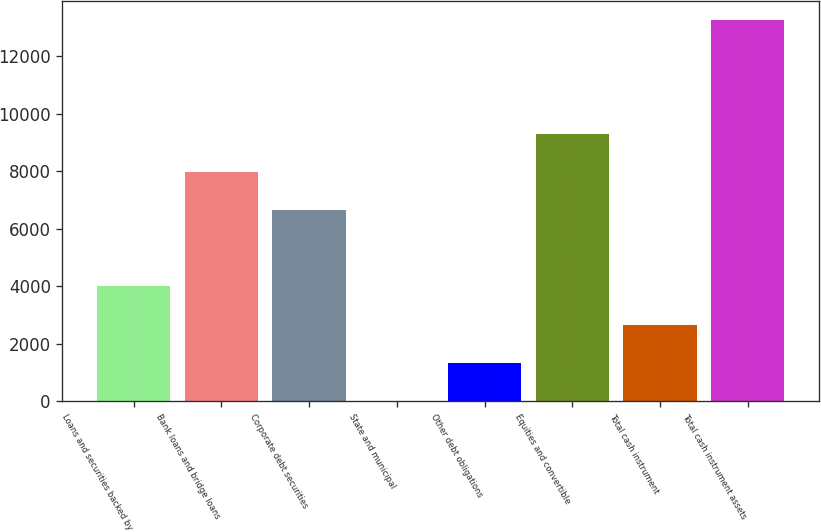Convert chart. <chart><loc_0><loc_0><loc_500><loc_500><bar_chart><fcel>Loans and securities backed by<fcel>Bank loans and bridge loans<fcel>Corporate debt securities<fcel>State and municipal<fcel>Other debt obligations<fcel>Equities and convertible<fcel>Total cash instrument<fcel>Total cash instrument assets<nl><fcel>3985.8<fcel>7962.6<fcel>6637<fcel>9<fcel>1334.6<fcel>9288.2<fcel>2660.2<fcel>13265<nl></chart> 